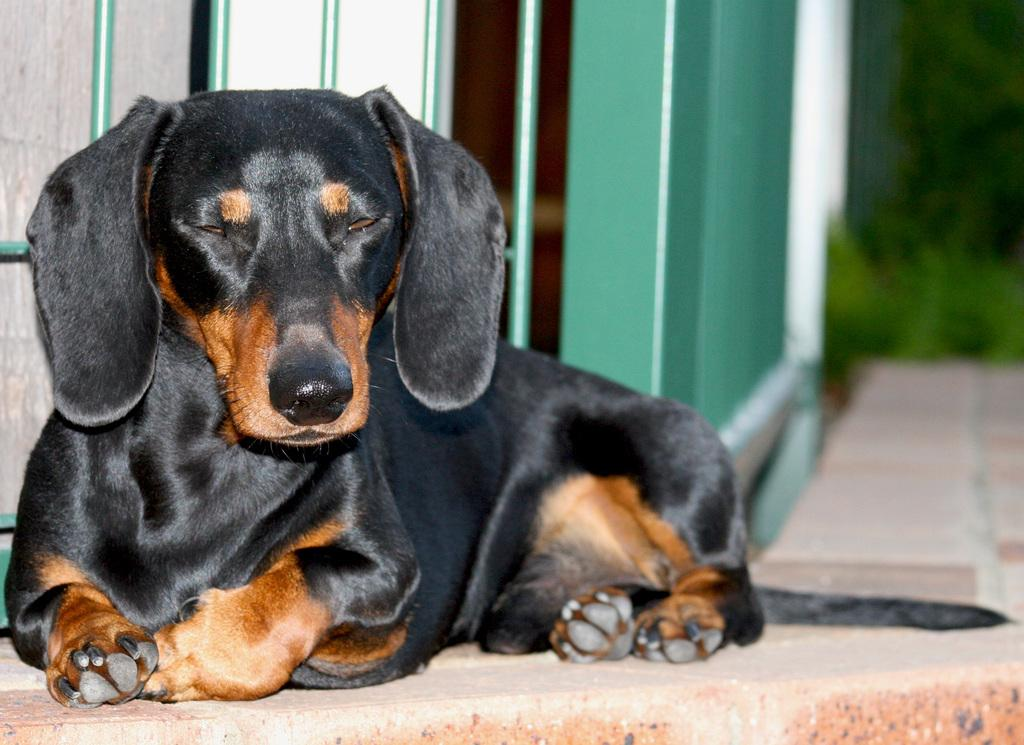What type of animal is present in the image? There is a dog in the image. What is the dog doing in the image? The dog is sitting on the ground. What can be seen in the background of the image? There are objects in the background of the image. How would you describe the background of the image? The background of the image is blurred. What invention is the dog using to communicate with the school during dinner? There is no invention, dinner, or school present in the image; it only features a dog sitting on the ground with a blurred background. 